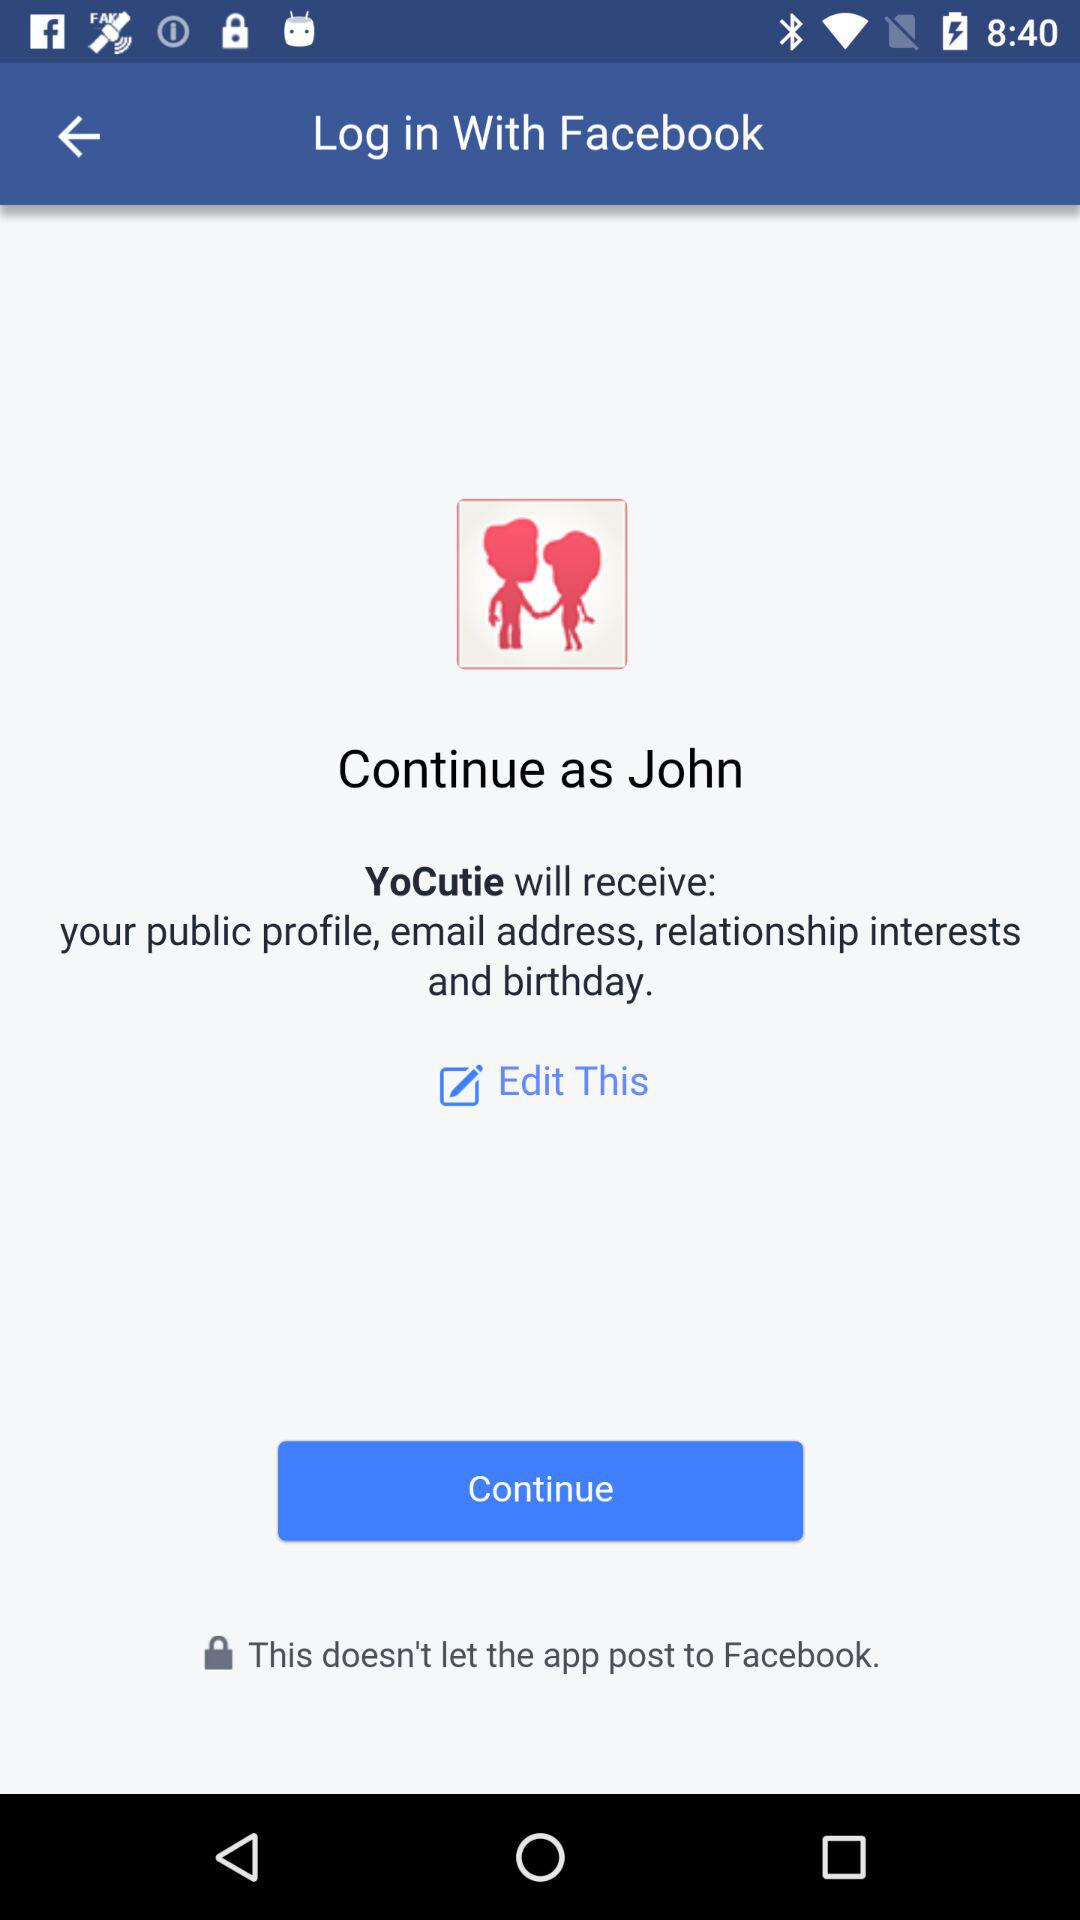What application is asking for permission? The application asking for permission is "YoCutie". 